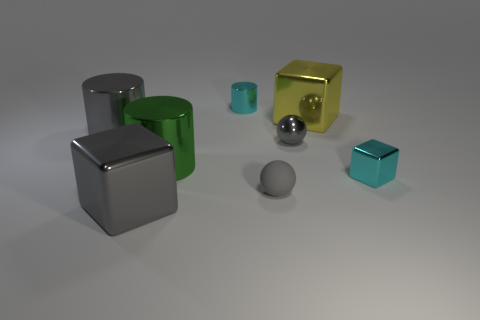Do the cyan cylinder and the large yellow object have the same material?
Your answer should be very brief. Yes. Does the cube left of the small cylinder have the same color as the metallic sphere?
Your response must be concise. Yes. The yellow object that is made of the same material as the tiny cylinder is what size?
Keep it short and to the point. Large. What shape is the tiny shiny object that is the same color as the matte object?
Your response must be concise. Sphere. The shiny cylinder that is the same size as the cyan metallic block is what color?
Offer a very short reply. Cyan. What material is the tiny object that is on the left side of the tiny gray shiny object and in front of the yellow cube?
Offer a very short reply. Rubber. Does the cylinder that is behind the large yellow metallic thing have the same color as the small block that is right of the small cyan cylinder?
Offer a very short reply. Yes. How many other things are the same size as the green metal object?
Keep it short and to the point. 3. There is a cyan thing that is in front of the cyan thing that is behind the cyan block; are there any cylinders on the left side of it?
Give a very brief answer. Yes. Does the ball in front of the big green cylinder have the same material as the small cyan cube?
Make the answer very short. No. 